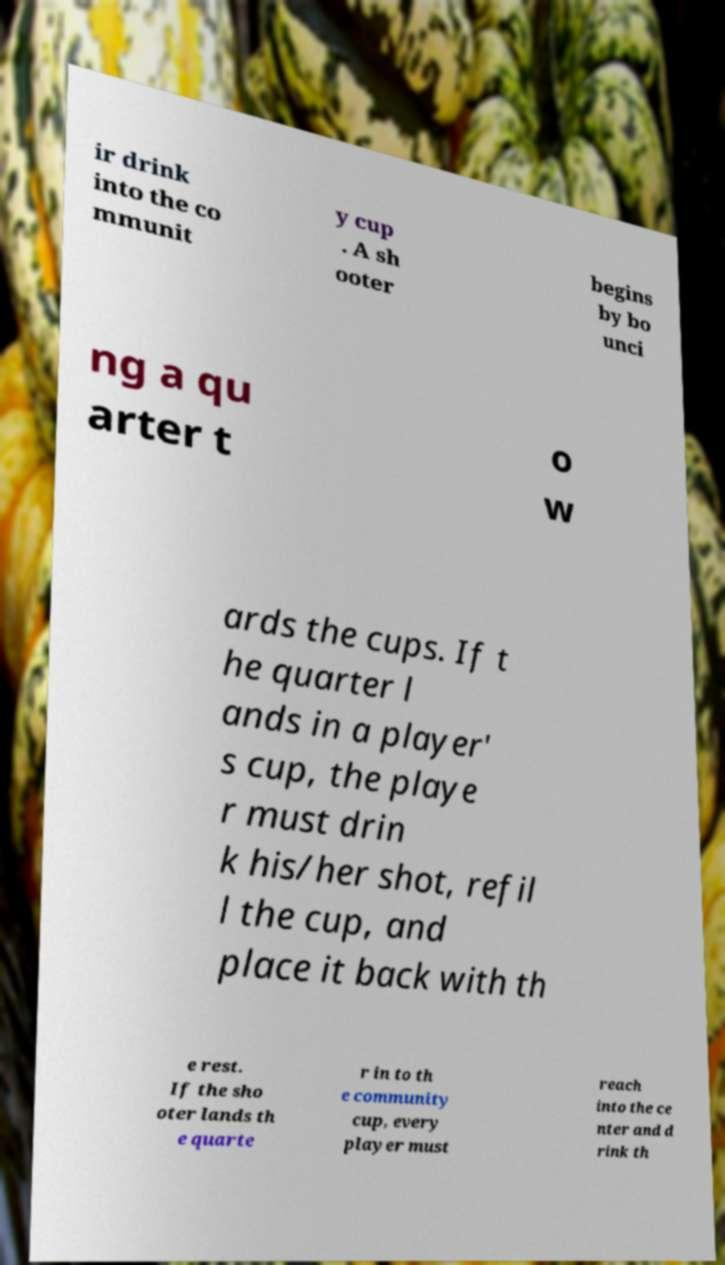Please read and relay the text visible in this image. What does it say? ir drink into the co mmunit y cup . A sh ooter begins by bo unci ng a qu arter t o w ards the cups. If t he quarter l ands in a player' s cup, the playe r must drin k his/her shot, refil l the cup, and place it back with th e rest. If the sho oter lands th e quarte r in to th e community cup, every player must reach into the ce nter and d rink th 